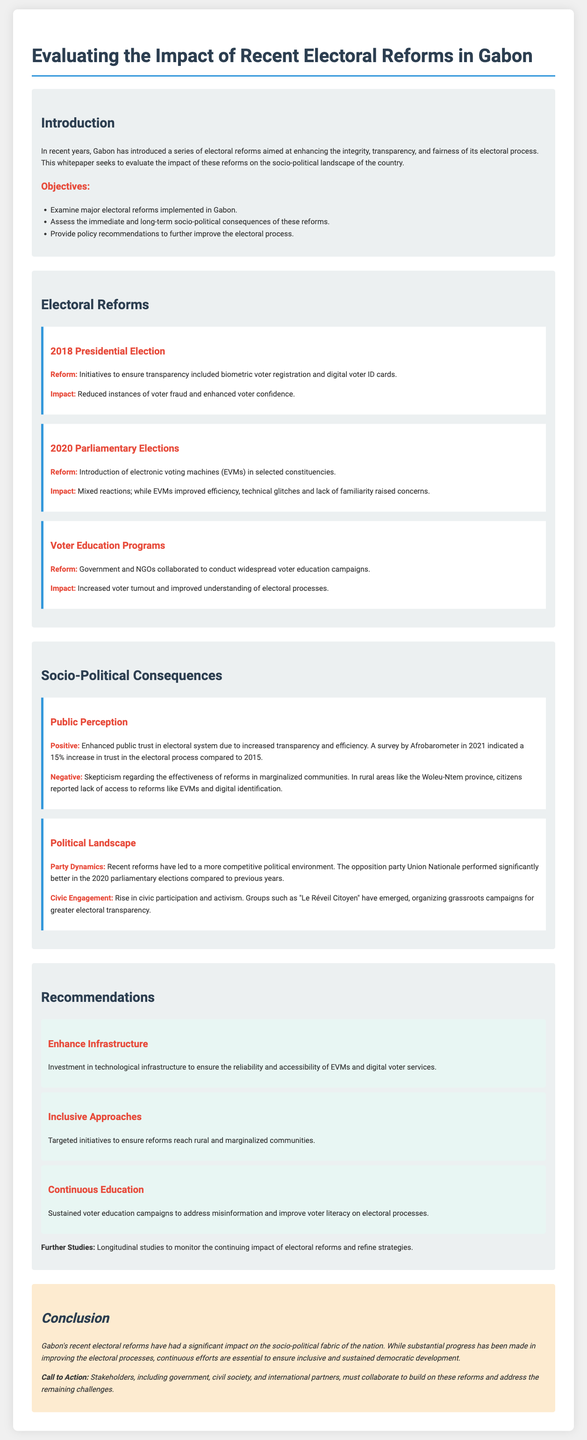What was the significant reform introduced in the 2018 Presidential Election? The reform was biometric voter registration and digital voter ID cards.
Answer: biometric voter registration and digital voter ID cards What was the percentage increase in trust in the electoral process reported by Afrobarometer in 2021? The survey indicated a 15% increase in trust in the electoral process compared to 2015.
Answer: 15% What was a major impact of the introduction of electronic voting machines in the 2020 Parliamentary Elections? The impact included improved efficiency but concerns over technical glitches and familiarity.
Answer: improved efficiency Which province reported skepticism regarding the effectiveness of electoral reforms? Citizens in rural areas like the Woleu-Ntem province expressed this skepticism.
Answer: Woleu-Ntem What initiative was recommended to reach rural and marginalized communities? The recommendation was for targeted initiatives to ensure reforms reach these communities.
Answer: targeted initiatives Which civic group emerged to promote electoral transparency? The group "Le Réveil Citoyen" organized grassroots campaigns for this purpose.
Answer: Le Réveil Citoyen What document type is this analysis? The document type is a whitepaper aimed at evaluating electoral reforms and their impacts.
Answer: whitepaper What year was the voter education campaign conducted in collaboration with NGOs? The voter education campaign took place following the reforms, prominently mentioned in relation to the recent elections.
Answer: 2020 What conclusion is drawn about Gabon's electoral reforms? The conclusion indicates substantial progress but emphasizes the need for continuous efforts to ensure inclusivity.
Answer: significant impact 